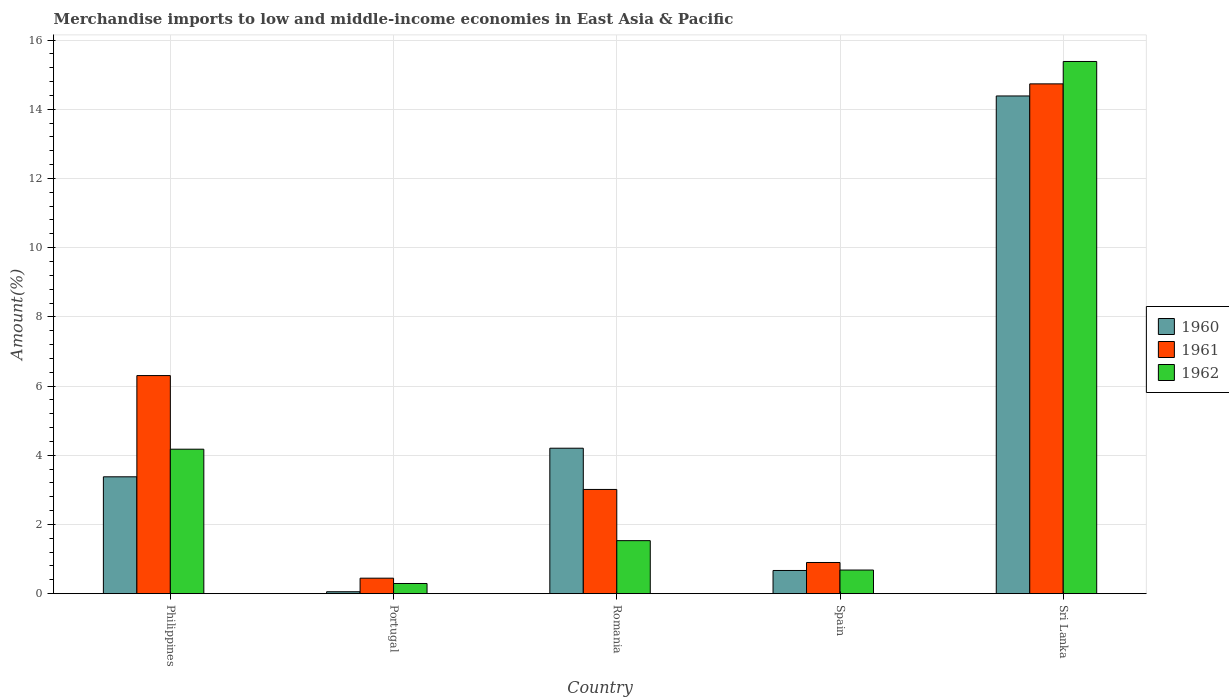How many bars are there on the 4th tick from the right?
Keep it short and to the point. 3. What is the label of the 3rd group of bars from the left?
Ensure brevity in your answer.  Romania. In how many cases, is the number of bars for a given country not equal to the number of legend labels?
Offer a very short reply. 0. What is the percentage of amount earned from merchandise imports in 1962 in Philippines?
Provide a short and direct response. 4.18. Across all countries, what is the maximum percentage of amount earned from merchandise imports in 1960?
Keep it short and to the point. 14.38. Across all countries, what is the minimum percentage of amount earned from merchandise imports in 1961?
Give a very brief answer. 0.45. In which country was the percentage of amount earned from merchandise imports in 1962 maximum?
Offer a terse response. Sri Lanka. In which country was the percentage of amount earned from merchandise imports in 1962 minimum?
Offer a very short reply. Portugal. What is the total percentage of amount earned from merchandise imports in 1962 in the graph?
Your response must be concise. 22.06. What is the difference between the percentage of amount earned from merchandise imports in 1962 in Philippines and that in Romania?
Keep it short and to the point. 2.64. What is the difference between the percentage of amount earned from merchandise imports in 1961 in Philippines and the percentage of amount earned from merchandise imports in 1962 in Spain?
Offer a terse response. 5.62. What is the average percentage of amount earned from merchandise imports in 1962 per country?
Keep it short and to the point. 4.41. What is the difference between the percentage of amount earned from merchandise imports of/in 1960 and percentage of amount earned from merchandise imports of/in 1961 in Spain?
Keep it short and to the point. -0.23. What is the ratio of the percentage of amount earned from merchandise imports in 1961 in Philippines to that in Romania?
Your response must be concise. 2.09. Is the percentage of amount earned from merchandise imports in 1961 in Philippines less than that in Sri Lanka?
Ensure brevity in your answer.  Yes. What is the difference between the highest and the second highest percentage of amount earned from merchandise imports in 1961?
Give a very brief answer. -11.72. What is the difference between the highest and the lowest percentage of amount earned from merchandise imports in 1960?
Offer a very short reply. 14.33. In how many countries, is the percentage of amount earned from merchandise imports in 1961 greater than the average percentage of amount earned from merchandise imports in 1961 taken over all countries?
Keep it short and to the point. 2. Is the sum of the percentage of amount earned from merchandise imports in 1961 in Portugal and Spain greater than the maximum percentage of amount earned from merchandise imports in 1962 across all countries?
Offer a terse response. No. Is it the case that in every country, the sum of the percentage of amount earned from merchandise imports in 1961 and percentage of amount earned from merchandise imports in 1960 is greater than the percentage of amount earned from merchandise imports in 1962?
Provide a short and direct response. Yes. How many countries are there in the graph?
Make the answer very short. 5. Where does the legend appear in the graph?
Give a very brief answer. Center right. How are the legend labels stacked?
Keep it short and to the point. Vertical. What is the title of the graph?
Provide a succinct answer. Merchandise imports to low and middle-income economies in East Asia & Pacific. Does "2005" appear as one of the legend labels in the graph?
Keep it short and to the point. No. What is the label or title of the X-axis?
Make the answer very short. Country. What is the label or title of the Y-axis?
Your answer should be very brief. Amount(%). What is the Amount(%) of 1960 in Philippines?
Provide a succinct answer. 3.38. What is the Amount(%) of 1961 in Philippines?
Make the answer very short. 6.3. What is the Amount(%) in 1962 in Philippines?
Give a very brief answer. 4.18. What is the Amount(%) of 1960 in Portugal?
Your answer should be very brief. 0.06. What is the Amount(%) of 1961 in Portugal?
Offer a very short reply. 0.45. What is the Amount(%) of 1962 in Portugal?
Offer a very short reply. 0.29. What is the Amount(%) in 1960 in Romania?
Provide a short and direct response. 4.2. What is the Amount(%) of 1961 in Romania?
Ensure brevity in your answer.  3.01. What is the Amount(%) in 1962 in Romania?
Keep it short and to the point. 1.53. What is the Amount(%) in 1960 in Spain?
Keep it short and to the point. 0.67. What is the Amount(%) of 1961 in Spain?
Offer a very short reply. 0.9. What is the Amount(%) of 1962 in Spain?
Your answer should be compact. 0.68. What is the Amount(%) of 1960 in Sri Lanka?
Give a very brief answer. 14.38. What is the Amount(%) in 1961 in Sri Lanka?
Ensure brevity in your answer.  14.73. What is the Amount(%) of 1962 in Sri Lanka?
Offer a terse response. 15.38. Across all countries, what is the maximum Amount(%) of 1960?
Your answer should be very brief. 14.38. Across all countries, what is the maximum Amount(%) in 1961?
Give a very brief answer. 14.73. Across all countries, what is the maximum Amount(%) in 1962?
Make the answer very short. 15.38. Across all countries, what is the minimum Amount(%) in 1960?
Keep it short and to the point. 0.06. Across all countries, what is the minimum Amount(%) in 1961?
Your answer should be very brief. 0.45. Across all countries, what is the minimum Amount(%) of 1962?
Your answer should be very brief. 0.29. What is the total Amount(%) of 1960 in the graph?
Your answer should be very brief. 22.69. What is the total Amount(%) in 1961 in the graph?
Your answer should be very brief. 25.4. What is the total Amount(%) of 1962 in the graph?
Your answer should be very brief. 22.06. What is the difference between the Amount(%) in 1960 in Philippines and that in Portugal?
Provide a succinct answer. 3.32. What is the difference between the Amount(%) in 1961 in Philippines and that in Portugal?
Provide a succinct answer. 5.86. What is the difference between the Amount(%) of 1962 in Philippines and that in Portugal?
Keep it short and to the point. 3.88. What is the difference between the Amount(%) of 1960 in Philippines and that in Romania?
Provide a succinct answer. -0.83. What is the difference between the Amount(%) in 1961 in Philippines and that in Romania?
Provide a short and direct response. 3.29. What is the difference between the Amount(%) in 1962 in Philippines and that in Romania?
Ensure brevity in your answer.  2.64. What is the difference between the Amount(%) of 1960 in Philippines and that in Spain?
Offer a very short reply. 2.71. What is the difference between the Amount(%) in 1961 in Philippines and that in Spain?
Your answer should be compact. 5.4. What is the difference between the Amount(%) of 1962 in Philippines and that in Spain?
Give a very brief answer. 3.49. What is the difference between the Amount(%) of 1960 in Philippines and that in Sri Lanka?
Make the answer very short. -11.01. What is the difference between the Amount(%) in 1961 in Philippines and that in Sri Lanka?
Give a very brief answer. -8.43. What is the difference between the Amount(%) in 1962 in Philippines and that in Sri Lanka?
Your response must be concise. -11.21. What is the difference between the Amount(%) of 1960 in Portugal and that in Romania?
Give a very brief answer. -4.15. What is the difference between the Amount(%) of 1961 in Portugal and that in Romania?
Ensure brevity in your answer.  -2.56. What is the difference between the Amount(%) in 1962 in Portugal and that in Romania?
Provide a succinct answer. -1.24. What is the difference between the Amount(%) in 1960 in Portugal and that in Spain?
Keep it short and to the point. -0.61. What is the difference between the Amount(%) of 1961 in Portugal and that in Spain?
Your answer should be very brief. -0.45. What is the difference between the Amount(%) of 1962 in Portugal and that in Spain?
Provide a succinct answer. -0.39. What is the difference between the Amount(%) of 1960 in Portugal and that in Sri Lanka?
Offer a terse response. -14.33. What is the difference between the Amount(%) in 1961 in Portugal and that in Sri Lanka?
Give a very brief answer. -14.29. What is the difference between the Amount(%) in 1962 in Portugal and that in Sri Lanka?
Your response must be concise. -15.09. What is the difference between the Amount(%) of 1960 in Romania and that in Spain?
Offer a terse response. 3.53. What is the difference between the Amount(%) of 1961 in Romania and that in Spain?
Your response must be concise. 2.11. What is the difference between the Amount(%) of 1962 in Romania and that in Spain?
Ensure brevity in your answer.  0.85. What is the difference between the Amount(%) in 1960 in Romania and that in Sri Lanka?
Provide a short and direct response. -10.18. What is the difference between the Amount(%) in 1961 in Romania and that in Sri Lanka?
Provide a short and direct response. -11.72. What is the difference between the Amount(%) of 1962 in Romania and that in Sri Lanka?
Your answer should be very brief. -13.85. What is the difference between the Amount(%) of 1960 in Spain and that in Sri Lanka?
Offer a very short reply. -13.71. What is the difference between the Amount(%) of 1961 in Spain and that in Sri Lanka?
Offer a terse response. -13.83. What is the difference between the Amount(%) of 1962 in Spain and that in Sri Lanka?
Make the answer very short. -14.7. What is the difference between the Amount(%) of 1960 in Philippines and the Amount(%) of 1961 in Portugal?
Give a very brief answer. 2.93. What is the difference between the Amount(%) in 1960 in Philippines and the Amount(%) in 1962 in Portugal?
Offer a terse response. 3.08. What is the difference between the Amount(%) in 1961 in Philippines and the Amount(%) in 1962 in Portugal?
Your answer should be very brief. 6.01. What is the difference between the Amount(%) of 1960 in Philippines and the Amount(%) of 1961 in Romania?
Provide a short and direct response. 0.37. What is the difference between the Amount(%) of 1960 in Philippines and the Amount(%) of 1962 in Romania?
Offer a terse response. 1.85. What is the difference between the Amount(%) of 1961 in Philippines and the Amount(%) of 1962 in Romania?
Your answer should be very brief. 4.77. What is the difference between the Amount(%) in 1960 in Philippines and the Amount(%) in 1961 in Spain?
Provide a succinct answer. 2.48. What is the difference between the Amount(%) in 1960 in Philippines and the Amount(%) in 1962 in Spain?
Keep it short and to the point. 2.69. What is the difference between the Amount(%) of 1961 in Philippines and the Amount(%) of 1962 in Spain?
Your response must be concise. 5.62. What is the difference between the Amount(%) of 1960 in Philippines and the Amount(%) of 1961 in Sri Lanka?
Offer a terse response. -11.36. What is the difference between the Amount(%) of 1960 in Philippines and the Amount(%) of 1962 in Sri Lanka?
Provide a succinct answer. -12. What is the difference between the Amount(%) of 1961 in Philippines and the Amount(%) of 1962 in Sri Lanka?
Your answer should be very brief. -9.08. What is the difference between the Amount(%) in 1960 in Portugal and the Amount(%) in 1961 in Romania?
Your answer should be very brief. -2.96. What is the difference between the Amount(%) in 1960 in Portugal and the Amount(%) in 1962 in Romania?
Keep it short and to the point. -1.48. What is the difference between the Amount(%) of 1961 in Portugal and the Amount(%) of 1962 in Romania?
Provide a succinct answer. -1.08. What is the difference between the Amount(%) in 1960 in Portugal and the Amount(%) in 1961 in Spain?
Your response must be concise. -0.85. What is the difference between the Amount(%) of 1960 in Portugal and the Amount(%) of 1962 in Spain?
Provide a short and direct response. -0.63. What is the difference between the Amount(%) in 1961 in Portugal and the Amount(%) in 1962 in Spain?
Offer a very short reply. -0.24. What is the difference between the Amount(%) in 1960 in Portugal and the Amount(%) in 1961 in Sri Lanka?
Your response must be concise. -14.68. What is the difference between the Amount(%) in 1960 in Portugal and the Amount(%) in 1962 in Sri Lanka?
Ensure brevity in your answer.  -15.32. What is the difference between the Amount(%) in 1961 in Portugal and the Amount(%) in 1962 in Sri Lanka?
Provide a short and direct response. -14.93. What is the difference between the Amount(%) of 1960 in Romania and the Amount(%) of 1961 in Spain?
Keep it short and to the point. 3.3. What is the difference between the Amount(%) of 1960 in Romania and the Amount(%) of 1962 in Spain?
Keep it short and to the point. 3.52. What is the difference between the Amount(%) in 1961 in Romania and the Amount(%) in 1962 in Spain?
Provide a short and direct response. 2.33. What is the difference between the Amount(%) of 1960 in Romania and the Amount(%) of 1961 in Sri Lanka?
Your response must be concise. -10.53. What is the difference between the Amount(%) in 1960 in Romania and the Amount(%) in 1962 in Sri Lanka?
Keep it short and to the point. -11.18. What is the difference between the Amount(%) of 1961 in Romania and the Amount(%) of 1962 in Sri Lanka?
Make the answer very short. -12.37. What is the difference between the Amount(%) in 1960 in Spain and the Amount(%) in 1961 in Sri Lanka?
Keep it short and to the point. -14.06. What is the difference between the Amount(%) of 1960 in Spain and the Amount(%) of 1962 in Sri Lanka?
Make the answer very short. -14.71. What is the difference between the Amount(%) in 1961 in Spain and the Amount(%) in 1962 in Sri Lanka?
Provide a succinct answer. -14.48. What is the average Amount(%) in 1960 per country?
Your answer should be very brief. 4.54. What is the average Amount(%) of 1961 per country?
Ensure brevity in your answer.  5.08. What is the average Amount(%) in 1962 per country?
Your response must be concise. 4.41. What is the difference between the Amount(%) in 1960 and Amount(%) in 1961 in Philippines?
Provide a succinct answer. -2.93. What is the difference between the Amount(%) in 1960 and Amount(%) in 1962 in Philippines?
Keep it short and to the point. -0.8. What is the difference between the Amount(%) in 1961 and Amount(%) in 1962 in Philippines?
Your response must be concise. 2.13. What is the difference between the Amount(%) of 1960 and Amount(%) of 1961 in Portugal?
Make the answer very short. -0.39. What is the difference between the Amount(%) in 1960 and Amount(%) in 1962 in Portugal?
Provide a succinct answer. -0.24. What is the difference between the Amount(%) in 1961 and Amount(%) in 1962 in Portugal?
Ensure brevity in your answer.  0.15. What is the difference between the Amount(%) in 1960 and Amount(%) in 1961 in Romania?
Provide a succinct answer. 1.19. What is the difference between the Amount(%) of 1960 and Amount(%) of 1962 in Romania?
Keep it short and to the point. 2.67. What is the difference between the Amount(%) in 1961 and Amount(%) in 1962 in Romania?
Your response must be concise. 1.48. What is the difference between the Amount(%) of 1960 and Amount(%) of 1961 in Spain?
Your response must be concise. -0.23. What is the difference between the Amount(%) in 1960 and Amount(%) in 1962 in Spain?
Ensure brevity in your answer.  -0.01. What is the difference between the Amount(%) of 1961 and Amount(%) of 1962 in Spain?
Your answer should be compact. 0.22. What is the difference between the Amount(%) in 1960 and Amount(%) in 1961 in Sri Lanka?
Give a very brief answer. -0.35. What is the difference between the Amount(%) of 1960 and Amount(%) of 1962 in Sri Lanka?
Provide a short and direct response. -1. What is the difference between the Amount(%) of 1961 and Amount(%) of 1962 in Sri Lanka?
Provide a succinct answer. -0.65. What is the ratio of the Amount(%) in 1960 in Philippines to that in Portugal?
Offer a very short reply. 60.74. What is the ratio of the Amount(%) of 1961 in Philippines to that in Portugal?
Your answer should be very brief. 14.09. What is the ratio of the Amount(%) in 1962 in Philippines to that in Portugal?
Provide a succinct answer. 14.2. What is the ratio of the Amount(%) of 1960 in Philippines to that in Romania?
Ensure brevity in your answer.  0.8. What is the ratio of the Amount(%) of 1961 in Philippines to that in Romania?
Offer a very short reply. 2.09. What is the ratio of the Amount(%) of 1962 in Philippines to that in Romania?
Provide a short and direct response. 2.73. What is the ratio of the Amount(%) in 1960 in Philippines to that in Spain?
Give a very brief answer. 5.04. What is the ratio of the Amount(%) in 1961 in Philippines to that in Spain?
Make the answer very short. 7. What is the ratio of the Amount(%) in 1962 in Philippines to that in Spain?
Offer a very short reply. 6.12. What is the ratio of the Amount(%) of 1960 in Philippines to that in Sri Lanka?
Your answer should be compact. 0.23. What is the ratio of the Amount(%) of 1961 in Philippines to that in Sri Lanka?
Provide a short and direct response. 0.43. What is the ratio of the Amount(%) of 1962 in Philippines to that in Sri Lanka?
Make the answer very short. 0.27. What is the ratio of the Amount(%) of 1960 in Portugal to that in Romania?
Provide a short and direct response. 0.01. What is the ratio of the Amount(%) in 1961 in Portugal to that in Romania?
Offer a very short reply. 0.15. What is the ratio of the Amount(%) in 1962 in Portugal to that in Romania?
Offer a very short reply. 0.19. What is the ratio of the Amount(%) in 1960 in Portugal to that in Spain?
Ensure brevity in your answer.  0.08. What is the ratio of the Amount(%) in 1961 in Portugal to that in Spain?
Your answer should be compact. 0.5. What is the ratio of the Amount(%) of 1962 in Portugal to that in Spain?
Your response must be concise. 0.43. What is the ratio of the Amount(%) of 1960 in Portugal to that in Sri Lanka?
Keep it short and to the point. 0. What is the ratio of the Amount(%) of 1961 in Portugal to that in Sri Lanka?
Offer a terse response. 0.03. What is the ratio of the Amount(%) in 1962 in Portugal to that in Sri Lanka?
Provide a short and direct response. 0.02. What is the ratio of the Amount(%) of 1960 in Romania to that in Spain?
Keep it short and to the point. 6.27. What is the ratio of the Amount(%) of 1961 in Romania to that in Spain?
Give a very brief answer. 3.34. What is the ratio of the Amount(%) of 1962 in Romania to that in Spain?
Provide a short and direct response. 2.24. What is the ratio of the Amount(%) in 1960 in Romania to that in Sri Lanka?
Give a very brief answer. 0.29. What is the ratio of the Amount(%) of 1961 in Romania to that in Sri Lanka?
Your answer should be compact. 0.2. What is the ratio of the Amount(%) in 1962 in Romania to that in Sri Lanka?
Your answer should be very brief. 0.1. What is the ratio of the Amount(%) of 1960 in Spain to that in Sri Lanka?
Offer a very short reply. 0.05. What is the ratio of the Amount(%) in 1961 in Spain to that in Sri Lanka?
Offer a terse response. 0.06. What is the ratio of the Amount(%) in 1962 in Spain to that in Sri Lanka?
Keep it short and to the point. 0.04. What is the difference between the highest and the second highest Amount(%) of 1960?
Give a very brief answer. 10.18. What is the difference between the highest and the second highest Amount(%) in 1961?
Keep it short and to the point. 8.43. What is the difference between the highest and the second highest Amount(%) in 1962?
Offer a terse response. 11.21. What is the difference between the highest and the lowest Amount(%) in 1960?
Offer a terse response. 14.33. What is the difference between the highest and the lowest Amount(%) in 1961?
Keep it short and to the point. 14.29. What is the difference between the highest and the lowest Amount(%) of 1962?
Your answer should be compact. 15.09. 